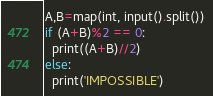<code> <loc_0><loc_0><loc_500><loc_500><_Python_>A,B=map(int, input().split())
if (A+B)%2 == 0:
  print((A+B)//2)
else:
  print('IMPOSSIBLE')
</code> 